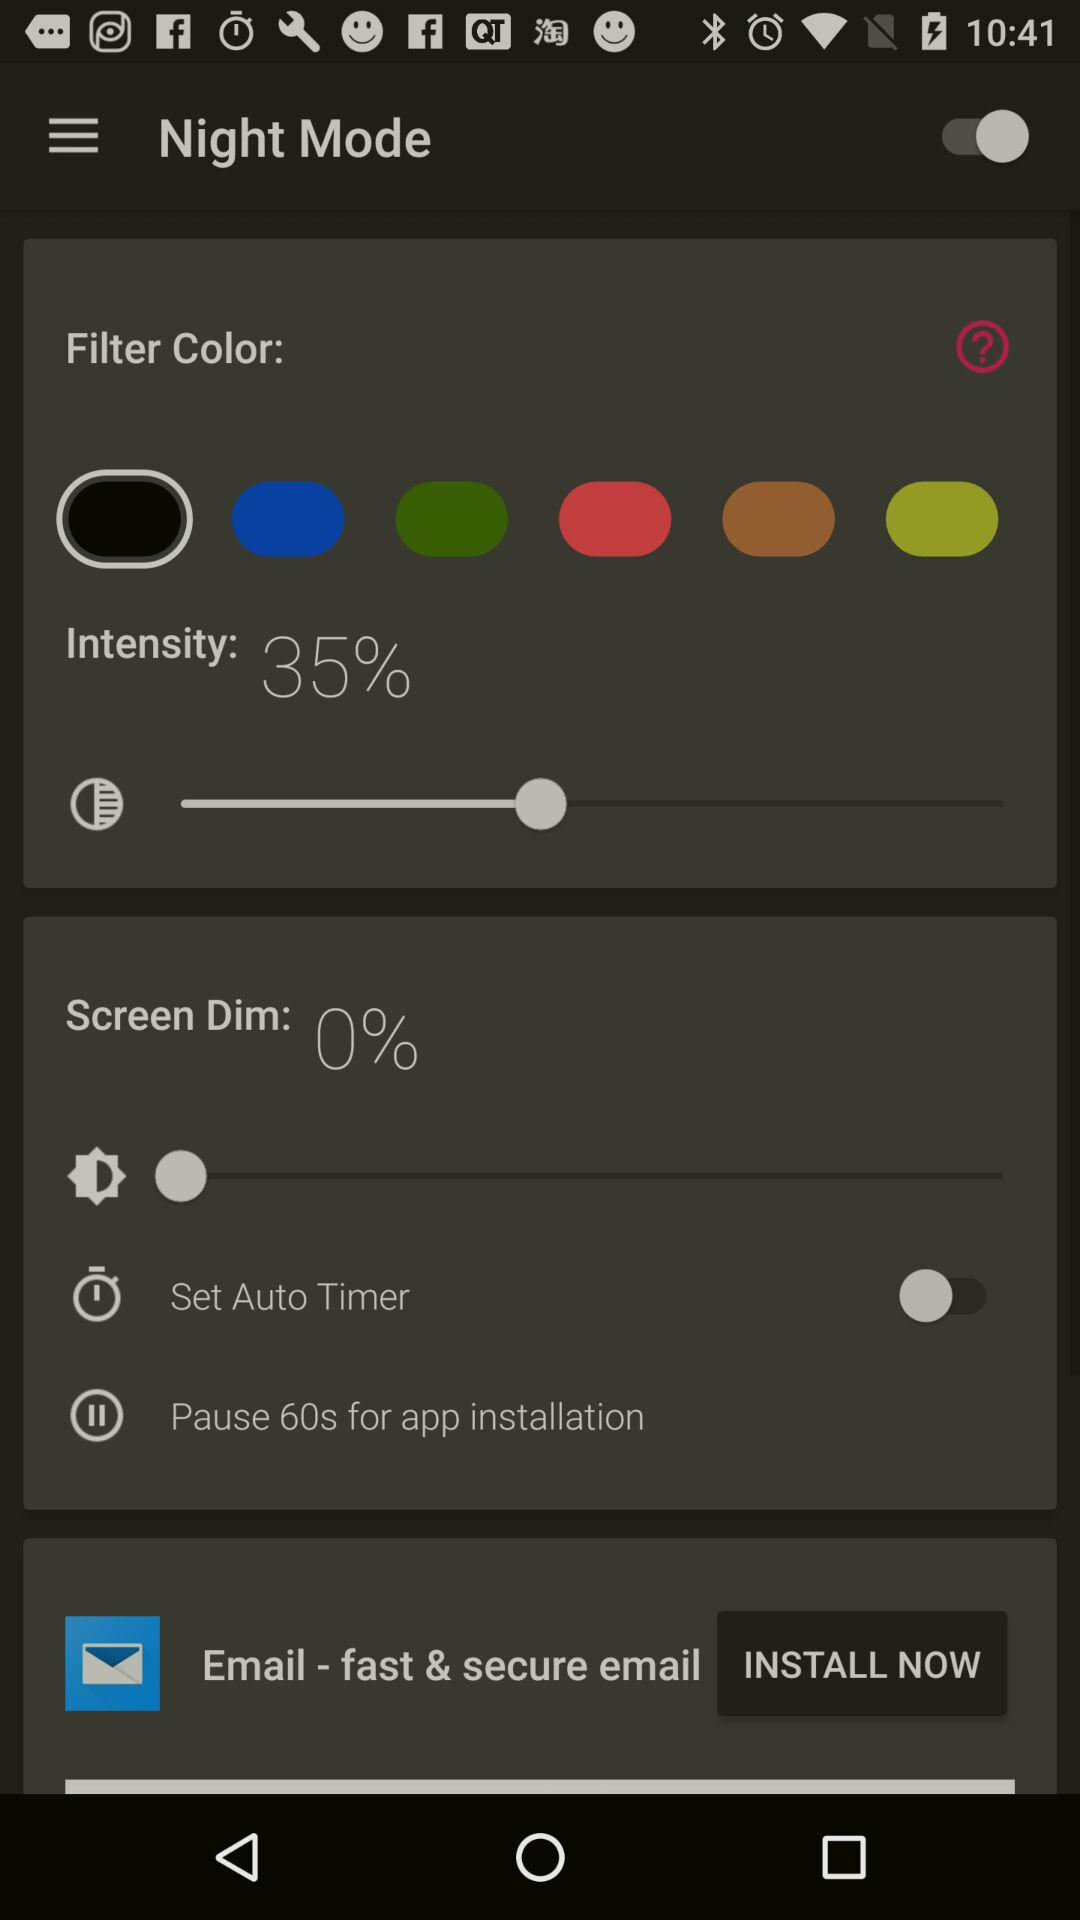What is the status of "Set Auto Timer"? The status of "Set Auto Timer" is "off". 